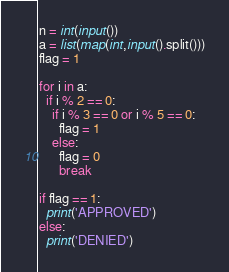<code> <loc_0><loc_0><loc_500><loc_500><_Python_>n = int(input())
a = list(map(int,input().split()))
flag = 1
     
for i in a:
  if i % 2 == 0:
    if i % 3 == 0 or i % 5 == 0:
      flag = 1
    else:
      flag = 0
      break
      
if flag == 1:
  print('APPROVED')
else:
  print('DENIED')</code> 